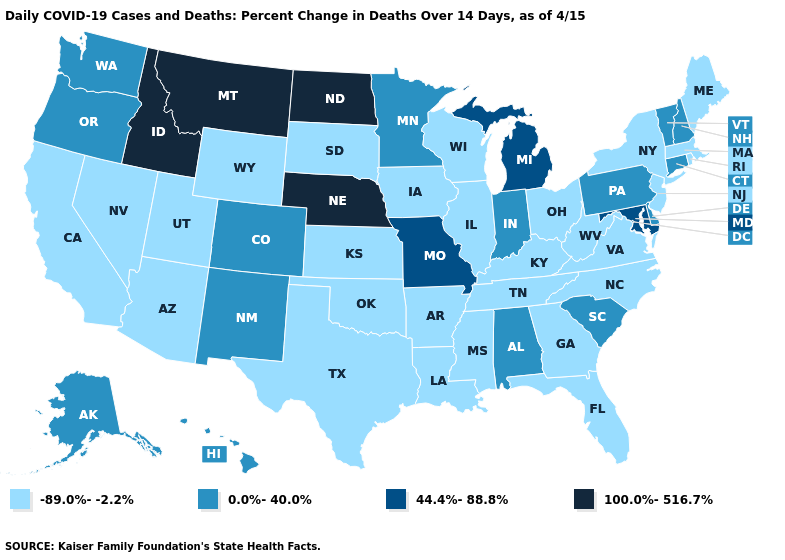What is the value of Colorado?
Short answer required. 0.0%-40.0%. What is the highest value in the USA?
Concise answer only. 100.0%-516.7%. Name the states that have a value in the range 100.0%-516.7%?
Give a very brief answer. Idaho, Montana, Nebraska, North Dakota. What is the highest value in the West ?
Answer briefly. 100.0%-516.7%. What is the value of Maryland?
Give a very brief answer. 44.4%-88.8%. Name the states that have a value in the range 100.0%-516.7%?
Concise answer only. Idaho, Montana, Nebraska, North Dakota. What is the lowest value in states that border Vermont?
Give a very brief answer. -89.0%--2.2%. Does the map have missing data?
Give a very brief answer. No. What is the highest value in the USA?
Short answer required. 100.0%-516.7%. Among the states that border Nevada , does Arizona have the highest value?
Concise answer only. No. Does Florida have the highest value in the South?
Answer briefly. No. What is the highest value in the Northeast ?
Answer briefly. 0.0%-40.0%. What is the value of California?
Concise answer only. -89.0%--2.2%. Name the states that have a value in the range -89.0%--2.2%?
Quick response, please. Arizona, Arkansas, California, Florida, Georgia, Illinois, Iowa, Kansas, Kentucky, Louisiana, Maine, Massachusetts, Mississippi, Nevada, New Jersey, New York, North Carolina, Ohio, Oklahoma, Rhode Island, South Dakota, Tennessee, Texas, Utah, Virginia, West Virginia, Wisconsin, Wyoming. Name the states that have a value in the range 44.4%-88.8%?
Write a very short answer. Maryland, Michigan, Missouri. 